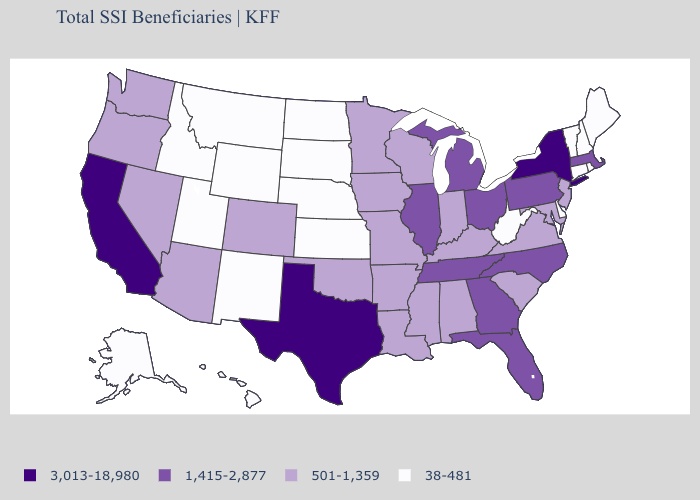Name the states that have a value in the range 1,415-2,877?
Write a very short answer. Florida, Georgia, Illinois, Massachusetts, Michigan, North Carolina, Ohio, Pennsylvania, Tennessee. What is the value of Tennessee?
Give a very brief answer. 1,415-2,877. What is the lowest value in the USA?
Write a very short answer. 38-481. What is the value of Minnesota?
Quick response, please. 501-1,359. What is the value of Georgia?
Be succinct. 1,415-2,877. Name the states that have a value in the range 1,415-2,877?
Be succinct. Florida, Georgia, Illinois, Massachusetts, Michigan, North Carolina, Ohio, Pennsylvania, Tennessee. What is the value of New York?
Concise answer only. 3,013-18,980. Among the states that border Nebraska , which have the highest value?
Keep it brief. Colorado, Iowa, Missouri. Name the states that have a value in the range 38-481?
Give a very brief answer. Alaska, Connecticut, Delaware, Hawaii, Idaho, Kansas, Maine, Montana, Nebraska, New Hampshire, New Mexico, North Dakota, Rhode Island, South Dakota, Utah, Vermont, West Virginia, Wyoming. What is the lowest value in states that border Virginia?
Give a very brief answer. 38-481. Name the states that have a value in the range 501-1,359?
Quick response, please. Alabama, Arizona, Arkansas, Colorado, Indiana, Iowa, Kentucky, Louisiana, Maryland, Minnesota, Mississippi, Missouri, Nevada, New Jersey, Oklahoma, Oregon, South Carolina, Virginia, Washington, Wisconsin. What is the highest value in the USA?
Write a very short answer. 3,013-18,980. Name the states that have a value in the range 3,013-18,980?
Be succinct. California, New York, Texas. What is the value of California?
Write a very short answer. 3,013-18,980. What is the lowest value in states that border North Carolina?
Give a very brief answer. 501-1,359. 